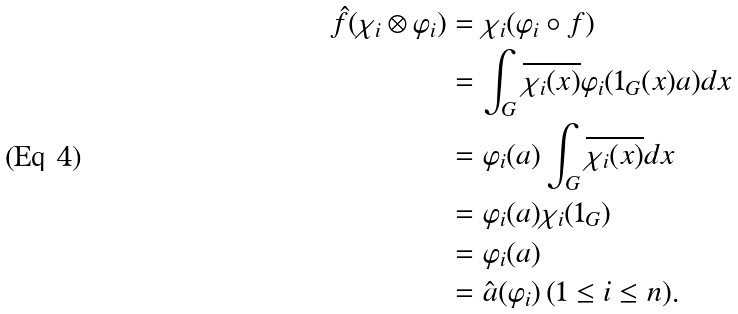Convert formula to latex. <formula><loc_0><loc_0><loc_500><loc_500>\hat { f } ( \chi _ { i } \otimes \varphi _ { i } ) & = \chi _ { i } ( \varphi _ { i } \circ f ) \\ & = \int _ { G } \overline { \chi _ { i } ( x ) } \varphi _ { i } ( 1 _ { G } ( x ) a ) d x \\ & = \varphi _ { i } ( a ) \int _ { G } \overline { \chi _ { i } ( x ) } d x \\ & = \varphi _ { i } ( a ) \chi _ { i } ( 1 _ { G } ) \\ & = \varphi _ { i } ( a ) \\ & = \hat { a } ( \varphi _ { i } ) \, ( 1 \leq i \leq n ) .</formula> 